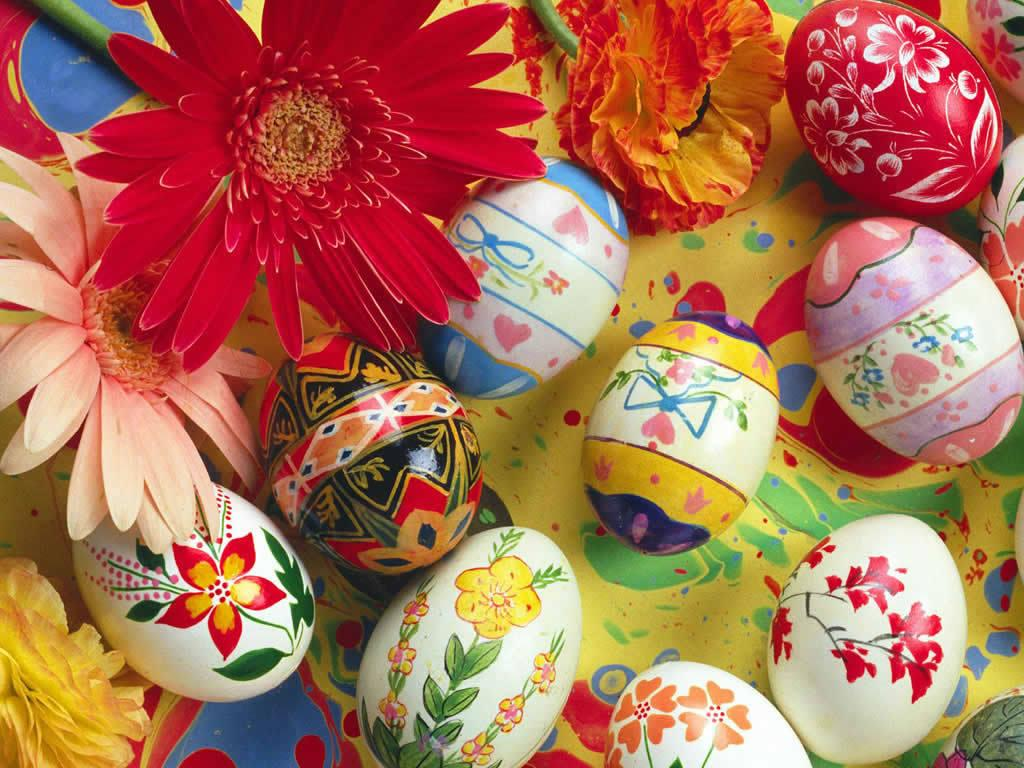What type of objects are featured in the image? There are designed eggs in the image. What is the background of the image? The eggs are on a colorful floor. What colors of flowers can be seen in the image? There are red, peach, yellow, and orange color flowers in the image. What type of wood is used to make the floor in the image? The image does not provide information about the type of wood used for the floor. 